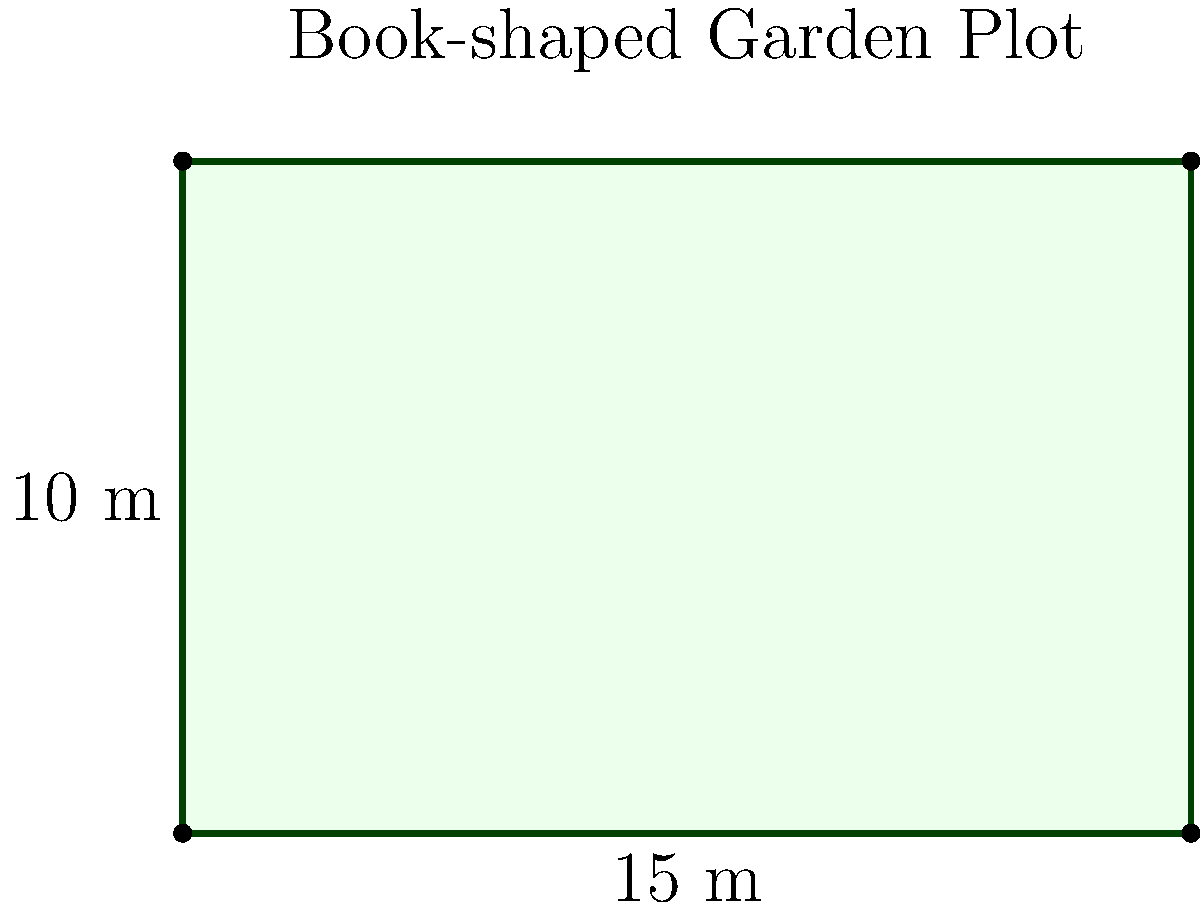As a writer seeking inspiration from nature, you decide to create a book-shaped garden plot to spark your creativity. The plot is rectangular, mirroring the shape of a book cover, with a length of 15 meters and a width of 10 meters. To ensure proper fencing, you need to calculate the perimeter of this unique garden. What is the total perimeter of your book-shaped garden plot in meters? To calculate the perimeter of the rectangular book-shaped garden plot, we need to follow these steps:

1. Identify the formula for the perimeter of a rectangle:
   Perimeter = 2 × (length + width)

2. Substitute the given dimensions:
   Length = 15 meters
   Width = 10 meters

3. Apply the formula:
   Perimeter = 2 × (15 m + 10 m)
   
4. Perform the addition inside the parentheses:
   Perimeter = 2 × (25 m)
   
5. Multiply:
   Perimeter = 50 meters

Therefore, the total perimeter of the book-shaped garden plot is 50 meters.
Answer: 50 meters 